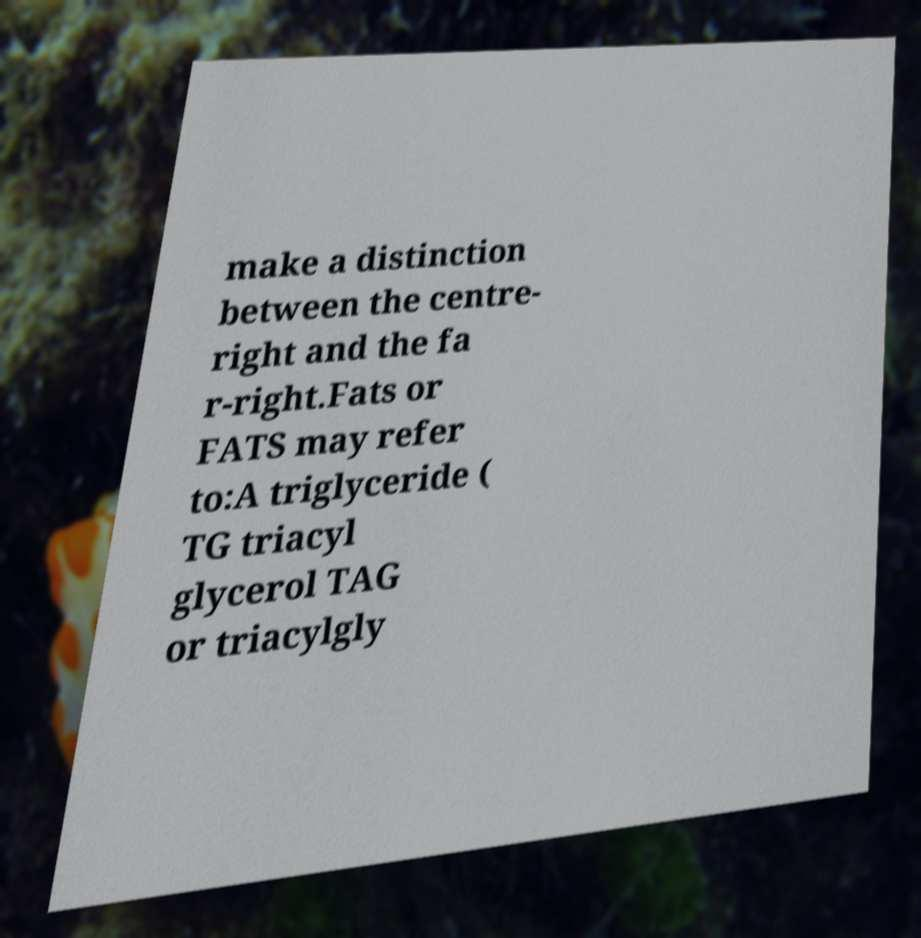Could you extract and type out the text from this image? make a distinction between the centre- right and the fa r-right.Fats or FATS may refer to:A triglyceride ( TG triacyl glycerol TAG or triacylgly 